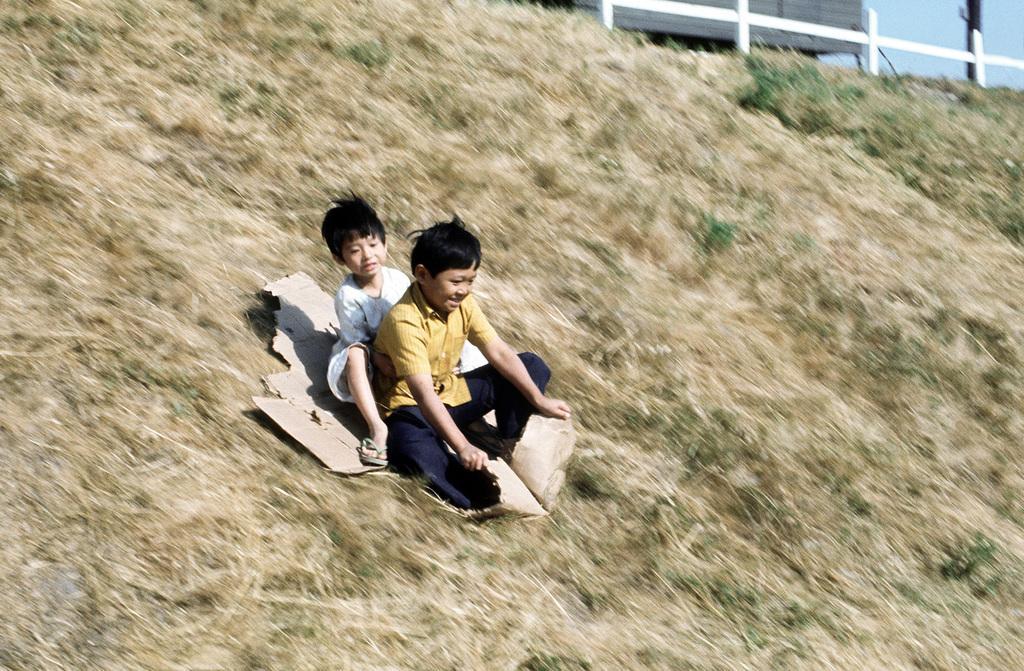In one or two sentences, can you explain what this image depicts? In this image I can see two children are sitting on a card which is placed on the ground. On the ground, I can see the grass. At the top of the image there is a railing and sky and also there is a truck. 